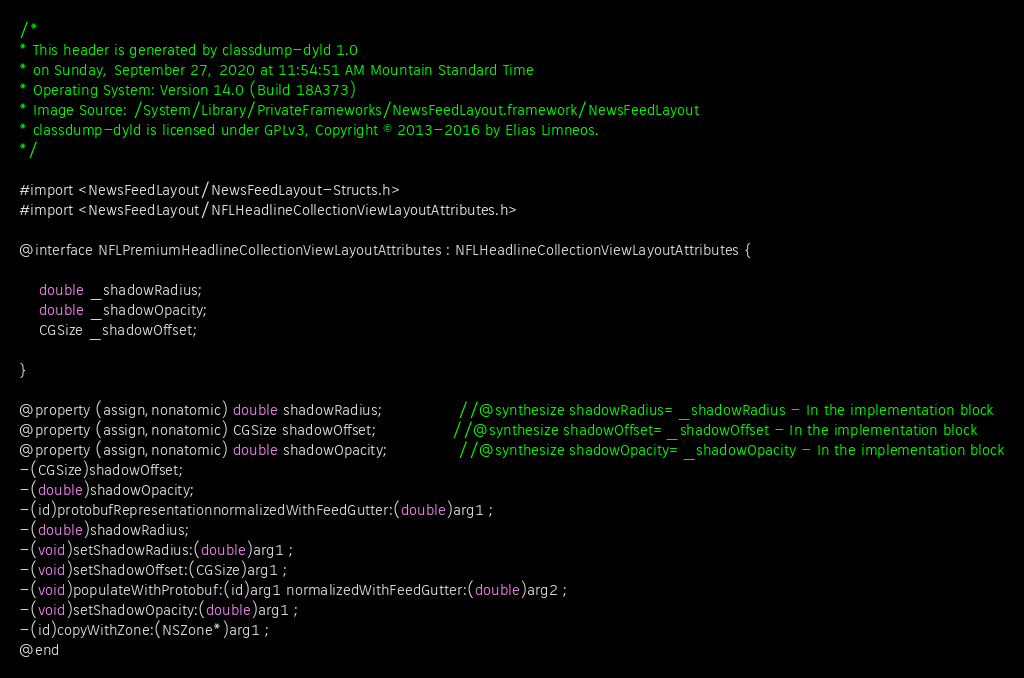Convert code to text. <code><loc_0><loc_0><loc_500><loc_500><_C_>/*
* This header is generated by classdump-dyld 1.0
* on Sunday, September 27, 2020 at 11:54:51 AM Mountain Standard Time
* Operating System: Version 14.0 (Build 18A373)
* Image Source: /System/Library/PrivateFrameworks/NewsFeedLayout.framework/NewsFeedLayout
* classdump-dyld is licensed under GPLv3, Copyright © 2013-2016 by Elias Limneos.
*/

#import <NewsFeedLayout/NewsFeedLayout-Structs.h>
#import <NewsFeedLayout/NFLHeadlineCollectionViewLayoutAttributes.h>

@interface NFLPremiumHeadlineCollectionViewLayoutAttributes : NFLHeadlineCollectionViewLayoutAttributes {

	double _shadowRadius;
	double _shadowOpacity;
	CGSize _shadowOffset;

}

@property (assign,nonatomic) double shadowRadius;               //@synthesize shadowRadius=_shadowRadius - In the implementation block
@property (assign,nonatomic) CGSize shadowOffset;               //@synthesize shadowOffset=_shadowOffset - In the implementation block
@property (assign,nonatomic) double shadowOpacity;              //@synthesize shadowOpacity=_shadowOpacity - In the implementation block
-(CGSize)shadowOffset;
-(double)shadowOpacity;
-(id)protobufRepresentationnormalizedWithFeedGutter:(double)arg1 ;
-(double)shadowRadius;
-(void)setShadowRadius:(double)arg1 ;
-(void)setShadowOffset:(CGSize)arg1 ;
-(void)populateWithProtobuf:(id)arg1 normalizedWithFeedGutter:(double)arg2 ;
-(void)setShadowOpacity:(double)arg1 ;
-(id)copyWithZone:(NSZone*)arg1 ;
@end

</code> 